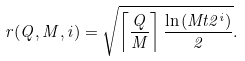Convert formula to latex. <formula><loc_0><loc_0><loc_500><loc_500>r ( Q , M , i ) = \sqrt { \left \lceil \frac { Q } { M } \right \rceil \frac { \ln { ( M t 2 ^ { i } ) } } { 2 } } .</formula> 